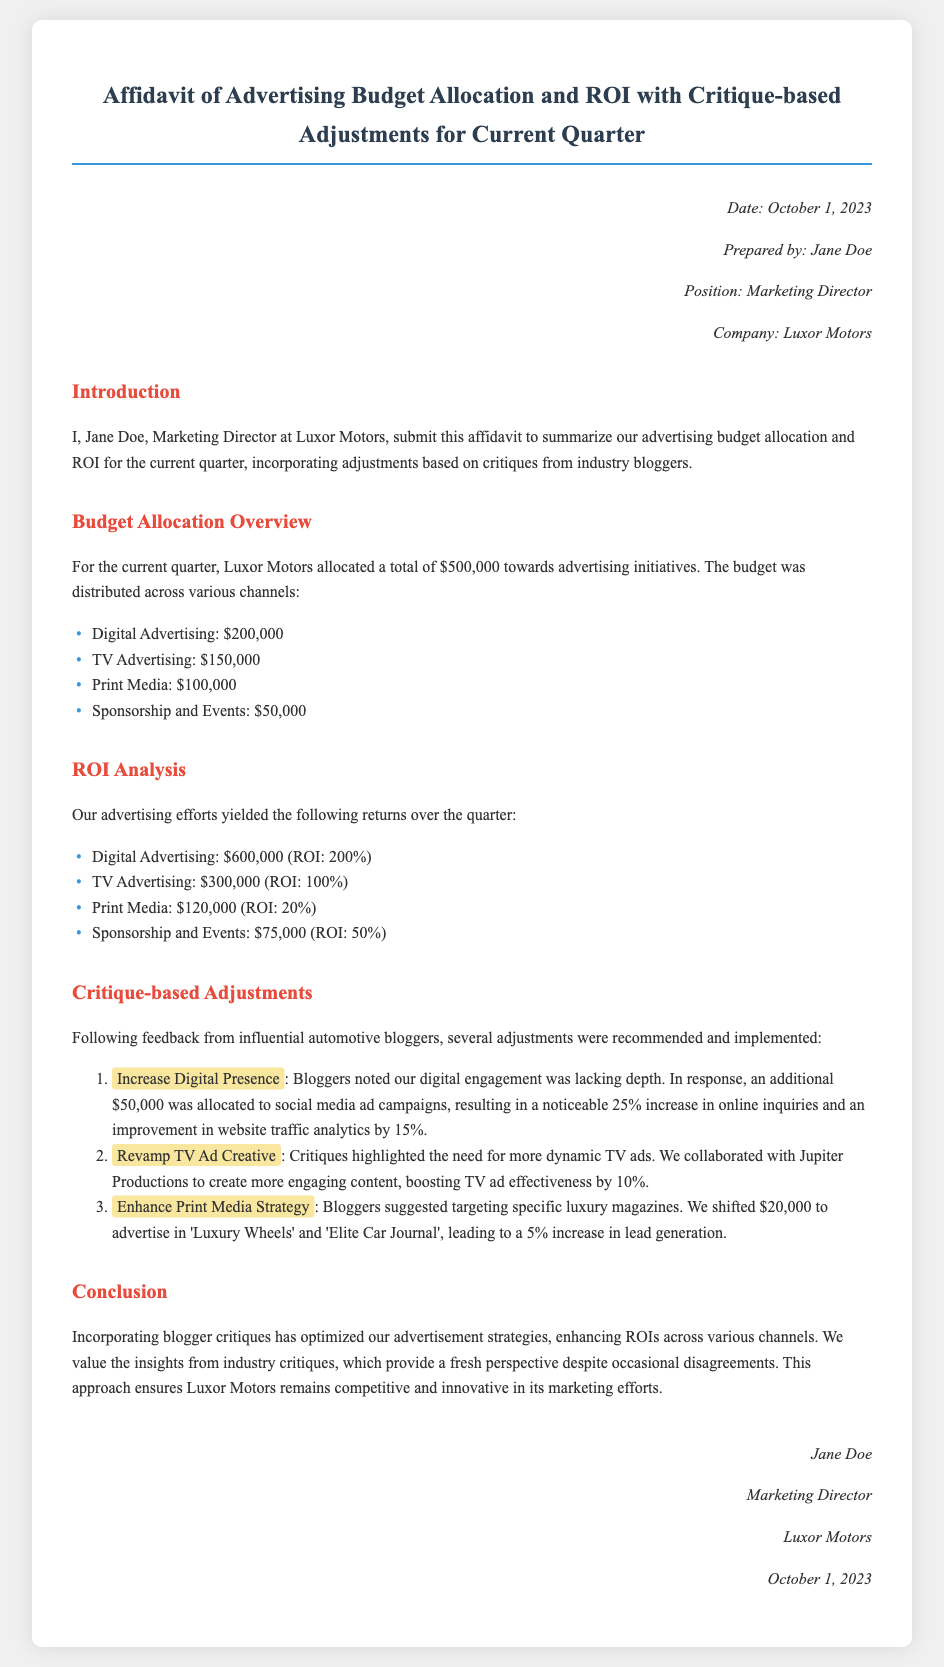what is the total advertising budget for the current quarter? The total budget allocated for advertising initiatives is stated clearly in the document.
Answer: $500,000 who prepared the affidavit? The name of the person who prepared the affidavit is mentioned in the header information.
Answer: Jane Doe what is the ROI for Digital Advertising? The ROI for Digital Advertising is specifically provided in the ROI Analysis section of the document.
Answer: 200% how much was allocated to TV Advertising? The budget allocation for TV Advertising is listed under the Budget Allocation Overview section.
Answer: $150,000 what critique-based adjustment resulted in a 25% increase in online inquiries? The specific adjustment that led to a notable increase is highlighted in the document.
Answer: Increase Digital Presence how much was shifted to target luxury magazines for Print Media? The document specifies how much budget was redirected towards advertising in luxury magazines under the Critique-based Adjustments section.
Answer: $20,000 what percentage increase in lead generation resulted from enhancing Print Media strategy? The increase in lead generation is stated in the context of the adjustments made based on critiques.
Answer: 5% what is the date of the affidavit? The date when the affidavit was prepared is mentioned in the header information.
Answer: October 1, 2023 who is the marketing director of Luxor Motors? The position and name of the person in charge of marketing are specified in the header info.
Answer: Jane Doe 